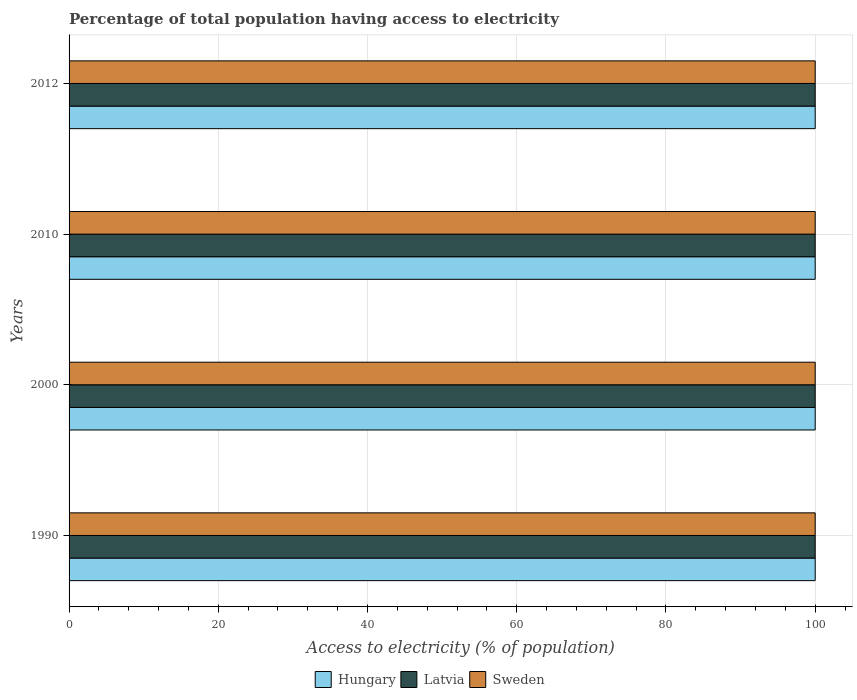How many different coloured bars are there?
Provide a short and direct response. 3. How many bars are there on the 3rd tick from the top?
Make the answer very short. 3. How many bars are there on the 1st tick from the bottom?
Your answer should be very brief. 3. What is the label of the 3rd group of bars from the top?
Give a very brief answer. 2000. What is the percentage of population that have access to electricity in Sweden in 2012?
Provide a succinct answer. 100. Across all years, what is the maximum percentage of population that have access to electricity in Sweden?
Your response must be concise. 100. Across all years, what is the minimum percentage of population that have access to electricity in Sweden?
Keep it short and to the point. 100. In which year was the percentage of population that have access to electricity in Sweden maximum?
Make the answer very short. 1990. What is the total percentage of population that have access to electricity in Latvia in the graph?
Offer a terse response. 400. What is the difference between the percentage of population that have access to electricity in Sweden in 1990 and the percentage of population that have access to electricity in Latvia in 2012?
Your answer should be compact. 0. What is the average percentage of population that have access to electricity in Latvia per year?
Give a very brief answer. 100. In how many years, is the percentage of population that have access to electricity in Sweden greater than 44 %?
Your answer should be compact. 4. What is the ratio of the percentage of population that have access to electricity in Sweden in 1990 to that in 2012?
Provide a short and direct response. 1. Is the difference between the percentage of population that have access to electricity in Sweden in 1990 and 2012 greater than the difference between the percentage of population that have access to electricity in Hungary in 1990 and 2012?
Provide a succinct answer. No. What is the difference between the highest and the second highest percentage of population that have access to electricity in Latvia?
Offer a terse response. 0. What is the difference between the highest and the lowest percentage of population that have access to electricity in Latvia?
Offer a terse response. 0. What does the 3rd bar from the top in 2000 represents?
Your response must be concise. Hungary. What does the 2nd bar from the bottom in 1990 represents?
Offer a very short reply. Latvia. Is it the case that in every year, the sum of the percentage of population that have access to electricity in Latvia and percentage of population that have access to electricity in Sweden is greater than the percentage of population that have access to electricity in Hungary?
Offer a very short reply. Yes. How many bars are there?
Your answer should be very brief. 12. How many years are there in the graph?
Give a very brief answer. 4. Does the graph contain any zero values?
Your answer should be very brief. No. What is the title of the graph?
Ensure brevity in your answer.  Percentage of total population having access to electricity. What is the label or title of the X-axis?
Ensure brevity in your answer.  Access to electricity (% of population). What is the Access to electricity (% of population) of Latvia in 1990?
Your answer should be very brief. 100. What is the Access to electricity (% of population) in Sweden in 1990?
Give a very brief answer. 100. What is the Access to electricity (% of population) in Latvia in 2000?
Make the answer very short. 100. What is the Access to electricity (% of population) in Hungary in 2010?
Provide a short and direct response. 100. What is the Access to electricity (% of population) of Latvia in 2010?
Keep it short and to the point. 100. What is the Access to electricity (% of population) in Sweden in 2010?
Provide a succinct answer. 100. What is the Access to electricity (% of population) of Sweden in 2012?
Offer a terse response. 100. Across all years, what is the maximum Access to electricity (% of population) in Hungary?
Provide a succinct answer. 100. Across all years, what is the maximum Access to electricity (% of population) of Latvia?
Offer a very short reply. 100. Across all years, what is the minimum Access to electricity (% of population) of Latvia?
Your response must be concise. 100. What is the total Access to electricity (% of population) in Hungary in the graph?
Ensure brevity in your answer.  400. What is the total Access to electricity (% of population) in Latvia in the graph?
Provide a short and direct response. 400. What is the total Access to electricity (% of population) in Sweden in the graph?
Make the answer very short. 400. What is the difference between the Access to electricity (% of population) in Hungary in 1990 and that in 2000?
Provide a succinct answer. 0. What is the difference between the Access to electricity (% of population) in Sweden in 1990 and that in 2000?
Keep it short and to the point. 0. What is the difference between the Access to electricity (% of population) in Hungary in 1990 and that in 2010?
Provide a succinct answer. 0. What is the difference between the Access to electricity (% of population) in Latvia in 1990 and that in 2010?
Your response must be concise. 0. What is the difference between the Access to electricity (% of population) of Sweden in 1990 and that in 2010?
Keep it short and to the point. 0. What is the difference between the Access to electricity (% of population) of Latvia in 1990 and that in 2012?
Your answer should be very brief. 0. What is the difference between the Access to electricity (% of population) in Sweden in 1990 and that in 2012?
Make the answer very short. 0. What is the difference between the Access to electricity (% of population) of Hungary in 2000 and that in 2010?
Offer a very short reply. 0. What is the difference between the Access to electricity (% of population) of Latvia in 2000 and that in 2010?
Your response must be concise. 0. What is the difference between the Access to electricity (% of population) in Sweden in 2000 and that in 2010?
Give a very brief answer. 0. What is the difference between the Access to electricity (% of population) in Latvia in 2000 and that in 2012?
Provide a succinct answer. 0. What is the difference between the Access to electricity (% of population) of Hungary in 2010 and that in 2012?
Provide a succinct answer. 0. What is the difference between the Access to electricity (% of population) in Latvia in 2010 and that in 2012?
Keep it short and to the point. 0. What is the difference between the Access to electricity (% of population) of Hungary in 1990 and the Access to electricity (% of population) of Sweden in 2000?
Offer a terse response. 0. What is the difference between the Access to electricity (% of population) of Hungary in 1990 and the Access to electricity (% of population) of Latvia in 2012?
Ensure brevity in your answer.  0. What is the difference between the Access to electricity (% of population) of Latvia in 1990 and the Access to electricity (% of population) of Sweden in 2012?
Make the answer very short. 0. What is the difference between the Access to electricity (% of population) in Latvia in 2000 and the Access to electricity (% of population) in Sweden in 2010?
Offer a very short reply. 0. What is the difference between the Access to electricity (% of population) of Hungary in 2000 and the Access to electricity (% of population) of Latvia in 2012?
Your response must be concise. 0. What is the difference between the Access to electricity (% of population) of Hungary in 2000 and the Access to electricity (% of population) of Sweden in 2012?
Offer a very short reply. 0. What is the difference between the Access to electricity (% of population) in Latvia in 2010 and the Access to electricity (% of population) in Sweden in 2012?
Provide a short and direct response. 0. What is the average Access to electricity (% of population) in Hungary per year?
Provide a short and direct response. 100. What is the average Access to electricity (% of population) of Latvia per year?
Your answer should be very brief. 100. What is the average Access to electricity (% of population) of Sweden per year?
Your answer should be very brief. 100. In the year 1990, what is the difference between the Access to electricity (% of population) of Hungary and Access to electricity (% of population) of Sweden?
Your answer should be compact. 0. In the year 1990, what is the difference between the Access to electricity (% of population) in Latvia and Access to electricity (% of population) in Sweden?
Provide a succinct answer. 0. In the year 2000, what is the difference between the Access to electricity (% of population) in Hungary and Access to electricity (% of population) in Latvia?
Give a very brief answer. 0. In the year 2010, what is the difference between the Access to electricity (% of population) of Hungary and Access to electricity (% of population) of Latvia?
Give a very brief answer. 0. In the year 2010, what is the difference between the Access to electricity (% of population) in Hungary and Access to electricity (% of population) in Sweden?
Your response must be concise. 0. In the year 2010, what is the difference between the Access to electricity (% of population) in Latvia and Access to electricity (% of population) in Sweden?
Make the answer very short. 0. In the year 2012, what is the difference between the Access to electricity (% of population) in Latvia and Access to electricity (% of population) in Sweden?
Provide a short and direct response. 0. What is the ratio of the Access to electricity (% of population) of Hungary in 1990 to that in 2000?
Ensure brevity in your answer.  1. What is the ratio of the Access to electricity (% of population) of Latvia in 1990 to that in 2000?
Give a very brief answer. 1. What is the ratio of the Access to electricity (% of population) in Hungary in 1990 to that in 2010?
Give a very brief answer. 1. What is the ratio of the Access to electricity (% of population) of Sweden in 1990 to that in 2010?
Your answer should be very brief. 1. What is the ratio of the Access to electricity (% of population) of Sweden in 1990 to that in 2012?
Give a very brief answer. 1. What is the ratio of the Access to electricity (% of population) in Sweden in 2000 to that in 2010?
Your response must be concise. 1. What is the ratio of the Access to electricity (% of population) in Latvia in 2010 to that in 2012?
Your answer should be compact. 1. What is the difference between the highest and the second highest Access to electricity (% of population) in Hungary?
Provide a short and direct response. 0. What is the difference between the highest and the second highest Access to electricity (% of population) of Latvia?
Provide a short and direct response. 0. 